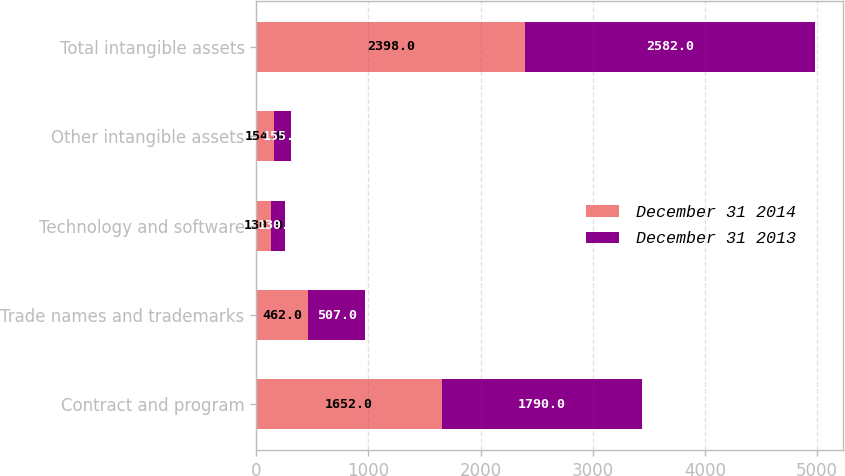Convert chart. <chart><loc_0><loc_0><loc_500><loc_500><stacked_bar_chart><ecel><fcel>Contract and program<fcel>Trade names and trademarks<fcel>Technology and software<fcel>Other intangible assets<fcel>Total intangible assets<nl><fcel>December 31 2014<fcel>1652<fcel>462<fcel>130<fcel>154<fcel>2398<nl><fcel>December 31 2013<fcel>1790<fcel>507<fcel>130<fcel>155<fcel>2582<nl></chart> 